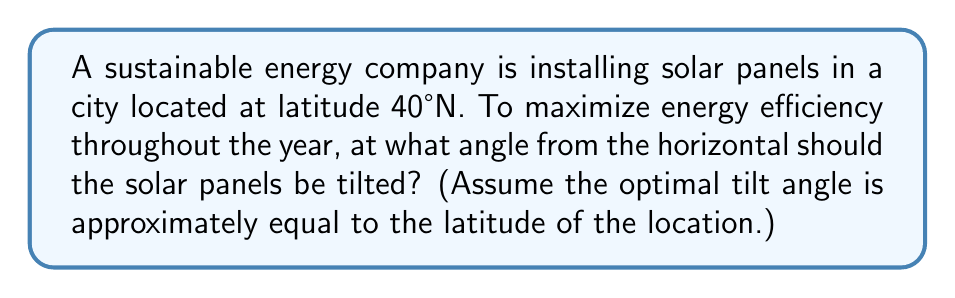Teach me how to tackle this problem. To determine the optimal angle for solar panel installation, we'll follow these steps:

1. Understand the relationship between latitude and optimal tilt angle:
   The rule of thumb for fixed solar panels is that the optimal tilt angle is approximately equal to the latitude of the location.

2. Identify the given information:
   - The city is located at latitude 40°N

3. Apply the rule:
   Optimal tilt angle ≈ Latitude
   $$ \text{Optimal tilt angle} \approx 40° $$

4. Interpret the result:
   The solar panels should be tilted at an angle of 40° from the horizontal, facing south.

5. Visualize the setup:
   [asy]
   import geometry;
   
   size(200);
   
   pair A = (0,0), B = (100,0), C = (100,84);
   draw(A--B--C--A);
   draw(B--(100,-20), dashed);
   
   label("Ground", (50,-10), S);
   label("Solar Panel", (50,42), NW);
   label("40°", (105,30), E);
   
   draw(arc(B,20,0,40), blue);
   [/asy]

This angle ensures that the panels receive optimal sunlight exposure throughout the year, balancing between summer and winter sun positions.
Answer: 40° 